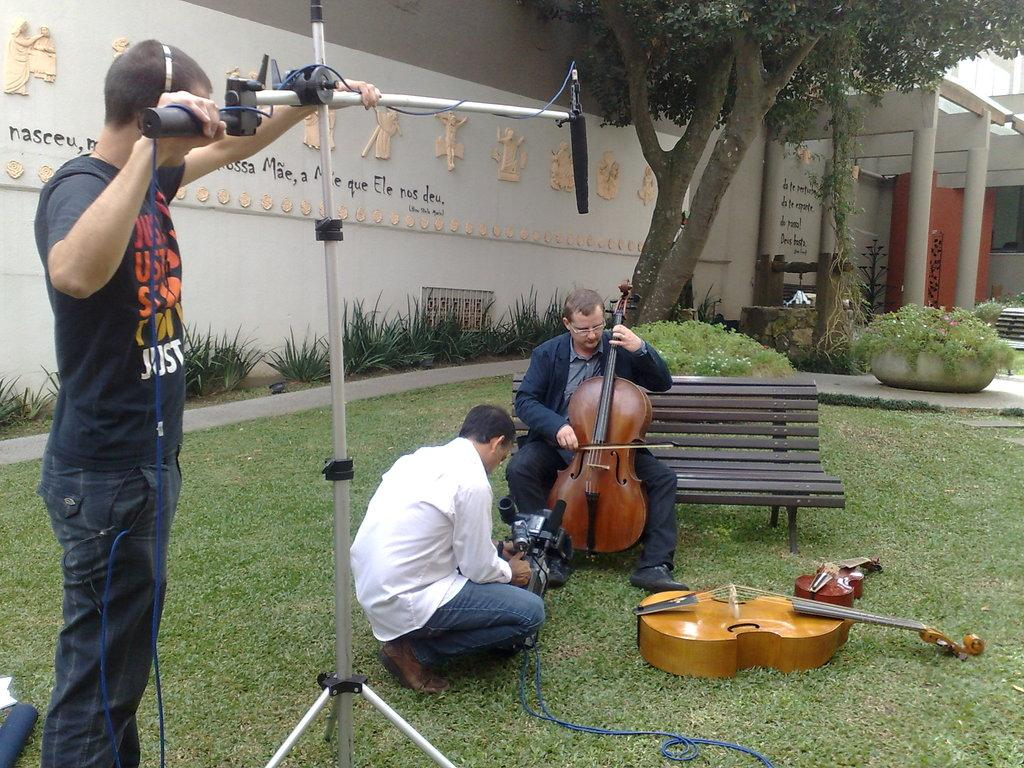What is the person on the bench doing in the image? The person is sitting on a bench and playing a guitar. Can you describe the person standing nearby? The man standing nearby is doing settings. What can be seen in the background of the image? There is a wall and a tree in the background. What type of income can be seen in the image? There is no reference to income in the image; it features a person playing a guitar and a man doing settings. What tool is the person using to adjust the guitar in the image? The person is not using a tool to adjust the guitar in the image; they are playing it. 